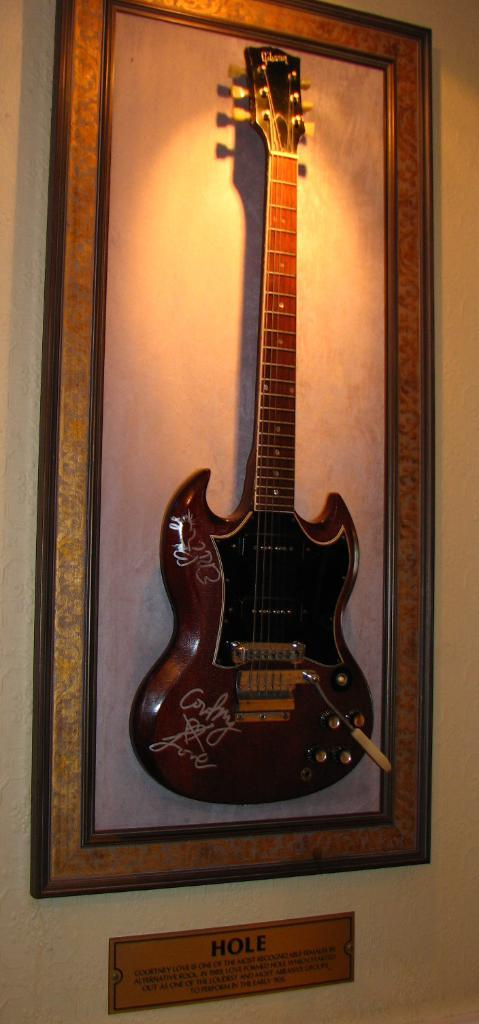<image>
Describe the image concisely. A Gibson branded Guitar with a wooden frame and a sign under it that has the word hole on it. 